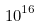Convert formula to latex. <formula><loc_0><loc_0><loc_500><loc_500>1 0 ^ { 1 6 }</formula> 